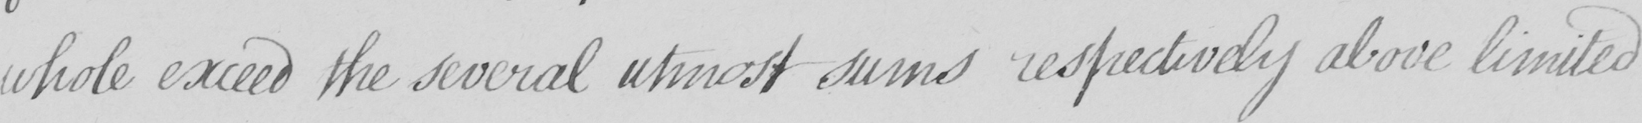What is written in this line of handwriting? whole exceed the several utmost sums respectively above limited 